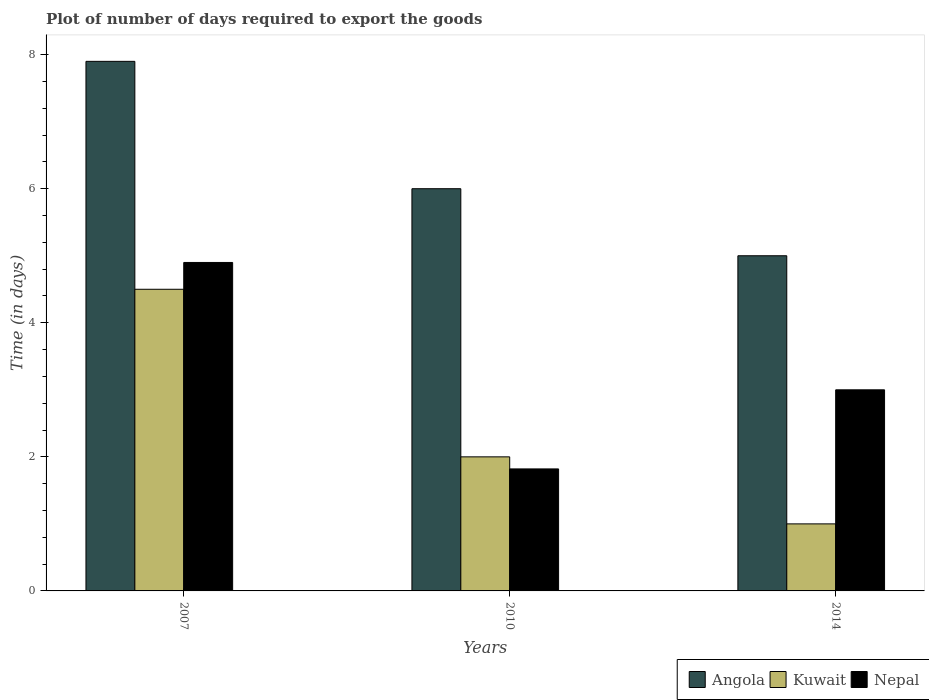Are the number of bars on each tick of the X-axis equal?
Provide a short and direct response. Yes. How many bars are there on the 3rd tick from the left?
Offer a very short reply. 3. Across all years, what is the maximum time required to export goods in Nepal?
Your answer should be compact. 4.9. Across all years, what is the minimum time required to export goods in Angola?
Your response must be concise. 5. In which year was the time required to export goods in Nepal maximum?
Your response must be concise. 2007. What is the difference between the time required to export goods in Angola in 2010 and that in 2014?
Offer a terse response. 1. What is the difference between the time required to export goods in Kuwait in 2007 and the time required to export goods in Angola in 2010?
Your answer should be compact. -1.5. What is the average time required to export goods in Nepal per year?
Give a very brief answer. 3.24. In the year 2007, what is the difference between the time required to export goods in Angola and time required to export goods in Nepal?
Give a very brief answer. 3. In how many years, is the time required to export goods in Angola greater than 5.2 days?
Provide a short and direct response. 2. What is the ratio of the time required to export goods in Nepal in 2010 to that in 2014?
Give a very brief answer. 0.61. Is the difference between the time required to export goods in Angola in 2010 and 2014 greater than the difference between the time required to export goods in Nepal in 2010 and 2014?
Provide a succinct answer. Yes. What is the difference between the highest and the second highest time required to export goods in Nepal?
Keep it short and to the point. 1.9. What is the difference between the highest and the lowest time required to export goods in Angola?
Ensure brevity in your answer.  2.9. What does the 3rd bar from the left in 2010 represents?
Your answer should be very brief. Nepal. What does the 2nd bar from the right in 2010 represents?
Keep it short and to the point. Kuwait. Are all the bars in the graph horizontal?
Make the answer very short. No. Are the values on the major ticks of Y-axis written in scientific E-notation?
Make the answer very short. No. Where does the legend appear in the graph?
Provide a short and direct response. Bottom right. How many legend labels are there?
Make the answer very short. 3. How are the legend labels stacked?
Keep it short and to the point. Horizontal. What is the title of the graph?
Your answer should be very brief. Plot of number of days required to export the goods. Does "Mexico" appear as one of the legend labels in the graph?
Provide a short and direct response. No. What is the label or title of the Y-axis?
Your response must be concise. Time (in days). What is the Time (in days) in Kuwait in 2007?
Make the answer very short. 4.5. What is the Time (in days) of Angola in 2010?
Provide a succinct answer. 6. What is the Time (in days) in Nepal in 2010?
Ensure brevity in your answer.  1.82. What is the Time (in days) in Angola in 2014?
Ensure brevity in your answer.  5. What is the Time (in days) in Kuwait in 2014?
Make the answer very short. 1. Across all years, what is the maximum Time (in days) of Nepal?
Make the answer very short. 4.9. Across all years, what is the minimum Time (in days) in Angola?
Provide a short and direct response. 5. Across all years, what is the minimum Time (in days) in Nepal?
Make the answer very short. 1.82. What is the total Time (in days) in Kuwait in the graph?
Ensure brevity in your answer.  7.5. What is the total Time (in days) in Nepal in the graph?
Your answer should be very brief. 9.72. What is the difference between the Time (in days) in Angola in 2007 and that in 2010?
Give a very brief answer. 1.9. What is the difference between the Time (in days) of Nepal in 2007 and that in 2010?
Your response must be concise. 3.08. What is the difference between the Time (in days) of Kuwait in 2007 and that in 2014?
Your response must be concise. 3.5. What is the difference between the Time (in days) of Nepal in 2010 and that in 2014?
Offer a very short reply. -1.18. What is the difference between the Time (in days) in Angola in 2007 and the Time (in days) in Nepal in 2010?
Your response must be concise. 6.08. What is the difference between the Time (in days) of Kuwait in 2007 and the Time (in days) of Nepal in 2010?
Provide a short and direct response. 2.68. What is the difference between the Time (in days) of Kuwait in 2007 and the Time (in days) of Nepal in 2014?
Your answer should be very brief. 1.5. What is the difference between the Time (in days) in Angola in 2010 and the Time (in days) in Kuwait in 2014?
Provide a succinct answer. 5. What is the difference between the Time (in days) of Angola in 2010 and the Time (in days) of Nepal in 2014?
Your response must be concise. 3. What is the difference between the Time (in days) in Kuwait in 2010 and the Time (in days) in Nepal in 2014?
Your answer should be very brief. -1. What is the average Time (in days) of Angola per year?
Keep it short and to the point. 6.3. What is the average Time (in days) of Nepal per year?
Keep it short and to the point. 3.24. In the year 2007, what is the difference between the Time (in days) of Angola and Time (in days) of Nepal?
Provide a short and direct response. 3. In the year 2007, what is the difference between the Time (in days) in Kuwait and Time (in days) in Nepal?
Your answer should be compact. -0.4. In the year 2010, what is the difference between the Time (in days) of Angola and Time (in days) of Nepal?
Make the answer very short. 4.18. In the year 2010, what is the difference between the Time (in days) in Kuwait and Time (in days) in Nepal?
Provide a short and direct response. 0.18. In the year 2014, what is the difference between the Time (in days) in Angola and Time (in days) in Kuwait?
Provide a succinct answer. 4. In the year 2014, what is the difference between the Time (in days) of Angola and Time (in days) of Nepal?
Provide a succinct answer. 2. What is the ratio of the Time (in days) in Angola in 2007 to that in 2010?
Provide a short and direct response. 1.32. What is the ratio of the Time (in days) of Kuwait in 2007 to that in 2010?
Give a very brief answer. 2.25. What is the ratio of the Time (in days) of Nepal in 2007 to that in 2010?
Keep it short and to the point. 2.69. What is the ratio of the Time (in days) in Angola in 2007 to that in 2014?
Make the answer very short. 1.58. What is the ratio of the Time (in days) of Kuwait in 2007 to that in 2014?
Your response must be concise. 4.5. What is the ratio of the Time (in days) in Nepal in 2007 to that in 2014?
Keep it short and to the point. 1.63. What is the ratio of the Time (in days) of Angola in 2010 to that in 2014?
Ensure brevity in your answer.  1.2. What is the ratio of the Time (in days) of Kuwait in 2010 to that in 2014?
Provide a succinct answer. 2. What is the ratio of the Time (in days) of Nepal in 2010 to that in 2014?
Provide a short and direct response. 0.61. What is the difference between the highest and the second highest Time (in days) in Kuwait?
Your answer should be compact. 2.5. What is the difference between the highest and the lowest Time (in days) of Nepal?
Make the answer very short. 3.08. 